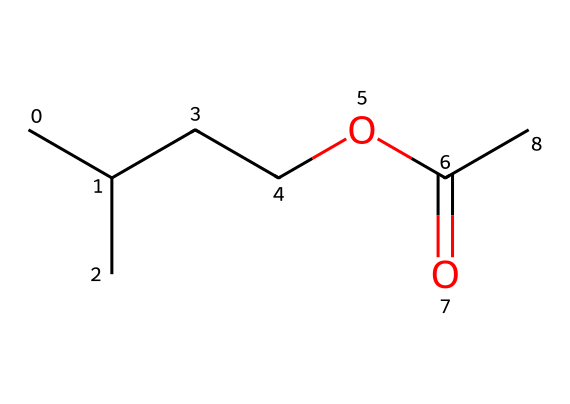What is the molecular formula of isoamyl acetate? The molecular formula can be derived from the elements present in the SMILES. Counting the carbon (C), hydrogen (H), and oxygen (O) atoms, we find 7 carbons, 14 hydrogens, and 2 oxygens. Therefore, the molecular formula is C7H14O2.
Answer: C7H14O2 How many carbon atoms are in isoamyl acetate? In the given SMILES representation, the structure can be observed to have a total of 7 carbon atoms.
Answer: 7 What functional group is present in isoamyl acetate? The structure includes a carbonyl group (C=O) adjacent to an ether linkage (C-O), characteristic of esters. This presence signifies that isoamyl acetate is an ester.
Answer: ester What is the total number of hydrogen atoms in isoamyl acetate? By examining the SMILES representation, counting all attached hydrogen atoms to the carbons and observing hydrogen connected to oxygen, we find there are 14 hydrogen atoms.
Answer: 14 How many oxygen atoms are present in isoamyl acetate? The SMILES structure shows two oxygen atoms incorporated within the ester functional group. Therefore, the total count of oxygen atoms is 2.
Answer: 2 What characteristic scent is isoamyl acetate associated with? Isoamyl acetate is commonly known for its banana-like scent derived from its molecular structure and composition.
Answer: banana Is isoamyl acetate a saturated or unsaturated ester? The structure can be analyzed for the presence of double bonds; since all carbon atoms are single-bonded without any C=C double bonds, it is classified as saturated.
Answer: saturated 